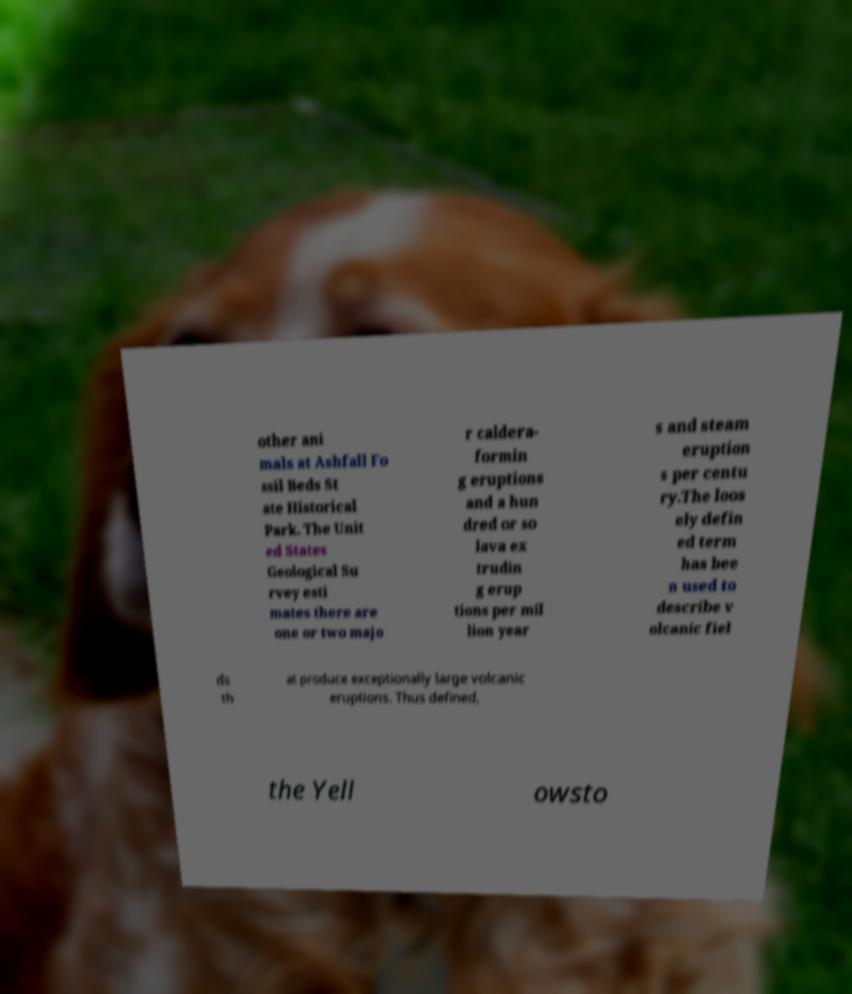For documentation purposes, I need the text within this image transcribed. Could you provide that? other ani mals at Ashfall Fo ssil Beds St ate Historical Park. The Unit ed States Geological Su rvey esti mates there are one or two majo r caldera- formin g eruptions and a hun dred or so lava ex trudin g erup tions per mil lion year s and steam eruption s per centu ry.The loos ely defin ed term has bee n used to describe v olcanic fiel ds th at produce exceptionally large volcanic eruptions. Thus defined, the Yell owsto 